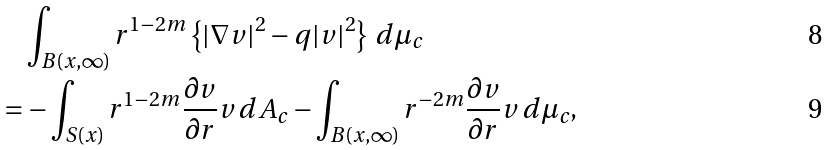<formula> <loc_0><loc_0><loc_500><loc_500>& \int _ { B ( x , \infty ) } r ^ { 1 - 2 m } \left \{ | \nabla v | ^ { 2 } - q | v | ^ { 2 } \right \} \, d \mu _ { c } \\ = & - \int _ { S ( x ) } r ^ { 1 - 2 m } \frac { \partial v } { \partial r } v \, d A _ { c } - \int _ { B ( x , \infty ) } r ^ { - 2 m } \frac { \partial v } { \partial r } v \, d \mu _ { c } ,</formula> 